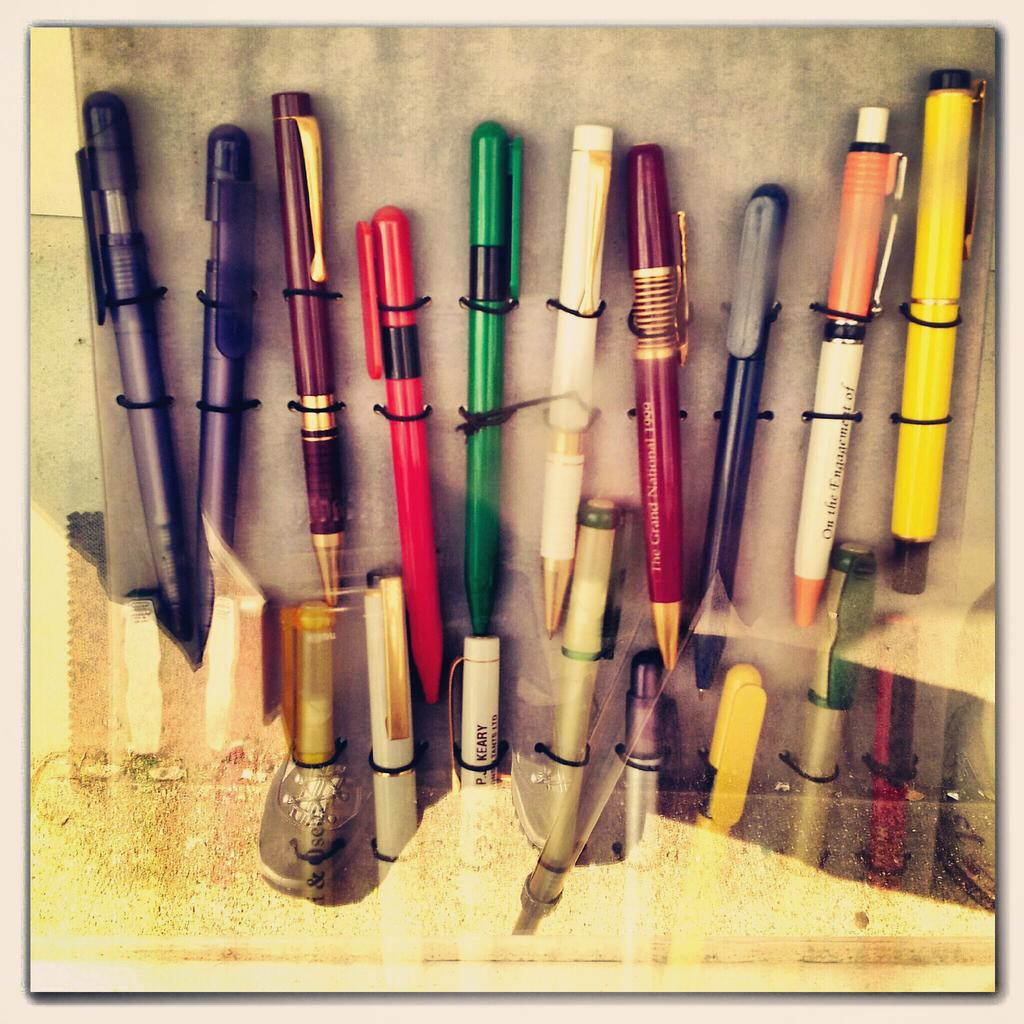What material is present in the image? There is glass in the image. What can be seen through the glass? Pens are visible through the glass. How are the pens connected to other objects? The pens are tied to black objects. What type of pest can be seen crawling on the pens in the image? There are no pests visible in the image; it only features glass, pens, and black objects. 